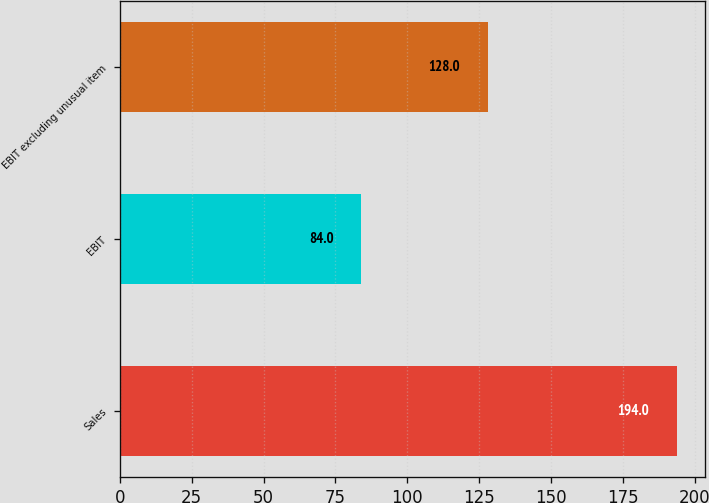Convert chart. <chart><loc_0><loc_0><loc_500><loc_500><bar_chart><fcel>Sales<fcel>EBIT<fcel>EBIT excluding unusual item<nl><fcel>194<fcel>84<fcel>128<nl></chart> 